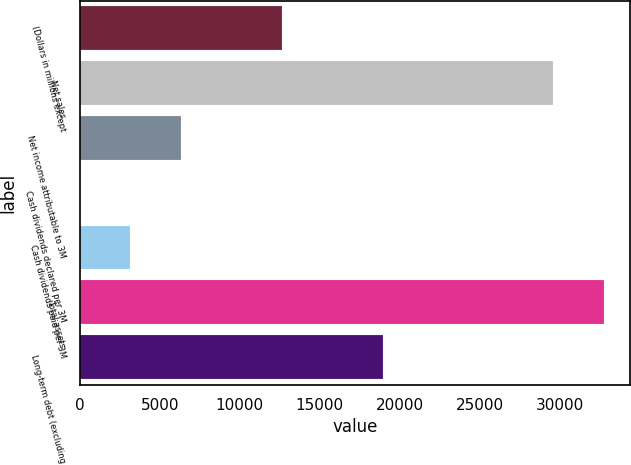<chart> <loc_0><loc_0><loc_500><loc_500><bar_chart><fcel>(Dollars in millions except<fcel>Net sales<fcel>Net income attributable to 3M<fcel>Cash dividends declared per 3M<fcel>Cash dividends paid per 3M<fcel>Total assets<fcel>Long-term debt (excluding<nl><fcel>12634.9<fcel>29611<fcel>6318.56<fcel>2.2<fcel>3160.38<fcel>32769.2<fcel>18951.3<nl></chart> 